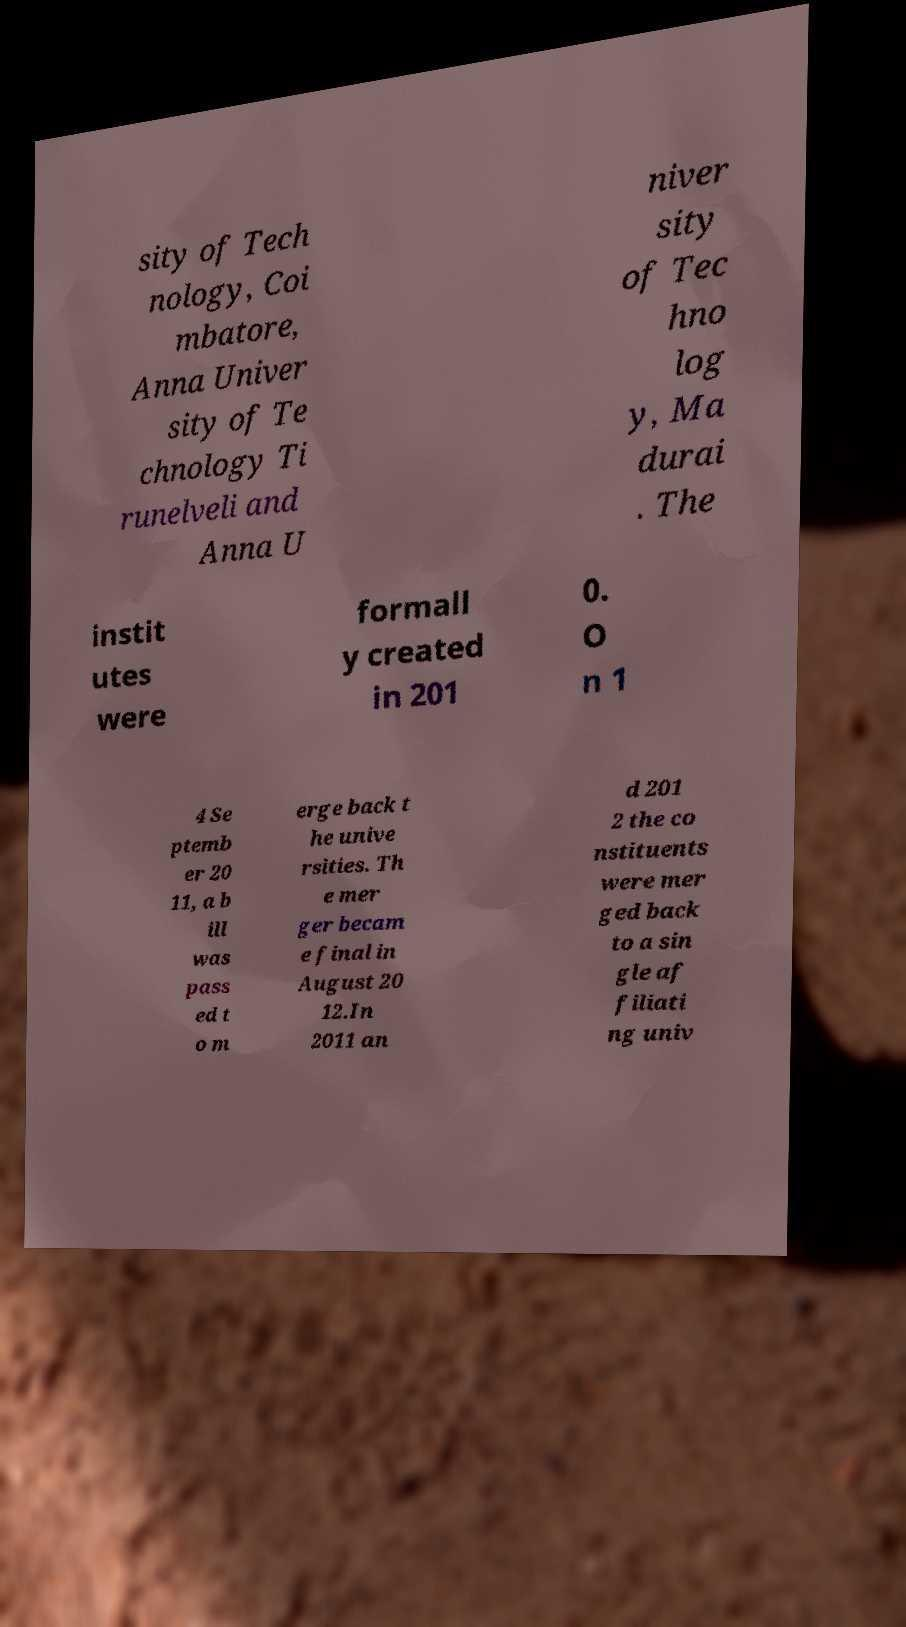For documentation purposes, I need the text within this image transcribed. Could you provide that? sity of Tech nology, Coi mbatore, Anna Univer sity of Te chnology Ti runelveli and Anna U niver sity of Tec hno log y, Ma durai . The instit utes were formall y created in 201 0. O n 1 4 Se ptemb er 20 11, a b ill was pass ed t o m erge back t he unive rsities. Th e mer ger becam e final in August 20 12.In 2011 an d 201 2 the co nstituents were mer ged back to a sin gle af filiati ng univ 